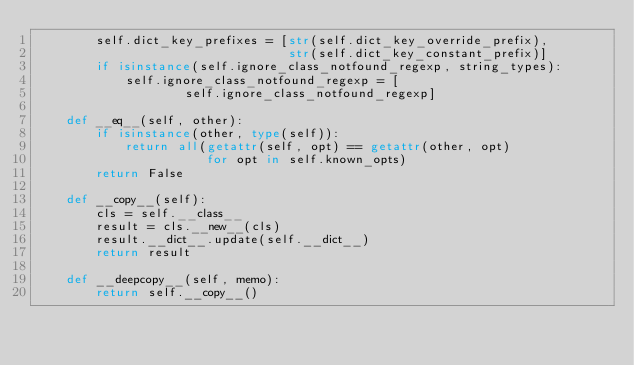<code> <loc_0><loc_0><loc_500><loc_500><_Python_>        self.dict_key_prefixes = [str(self.dict_key_override_prefix),
                                  str(self.dict_key_constant_prefix)]
        if isinstance(self.ignore_class_notfound_regexp, string_types):
            self.ignore_class_notfound_regexp = [
                    self.ignore_class_notfound_regexp]

    def __eq__(self, other):
        if isinstance(other, type(self)):
            return all(getattr(self, opt) == getattr(other, opt)
                       for opt in self.known_opts)
        return False

    def __copy__(self):
        cls = self.__class__
        result = cls.__new__(cls)
        result.__dict__.update(self.__dict__)
        return result

    def __deepcopy__(self, memo):
        return self.__copy__()
</code> 